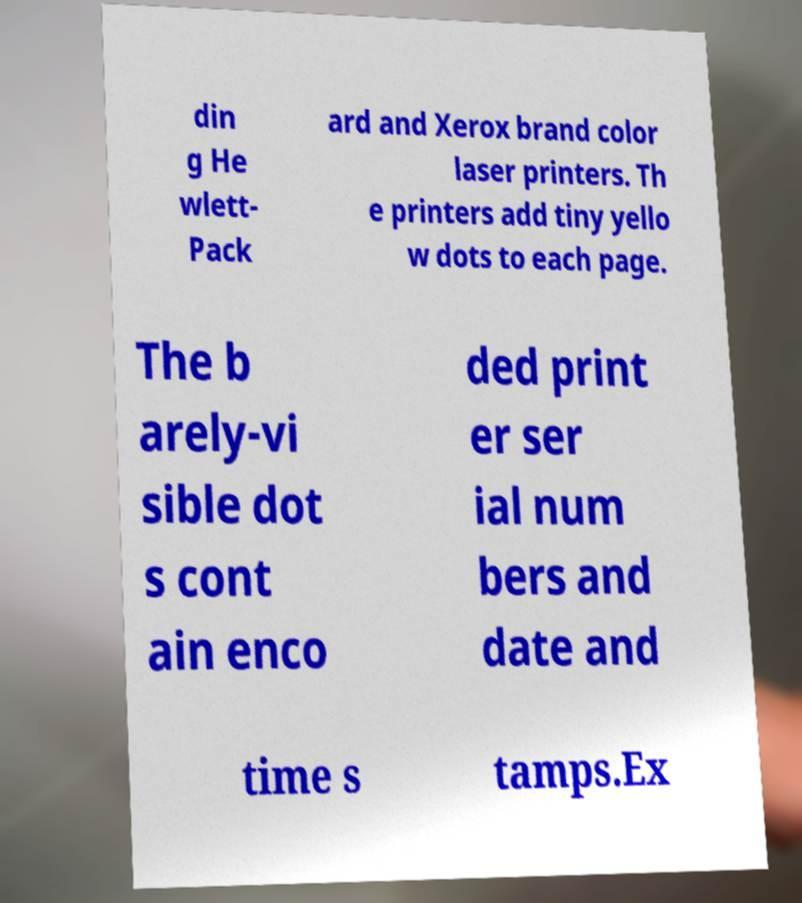Can you accurately transcribe the text from the provided image for me? din g He wlett- Pack ard and Xerox brand color laser printers. Th e printers add tiny yello w dots to each page. The b arely-vi sible dot s cont ain enco ded print er ser ial num bers and date and time s tamps.Ex 